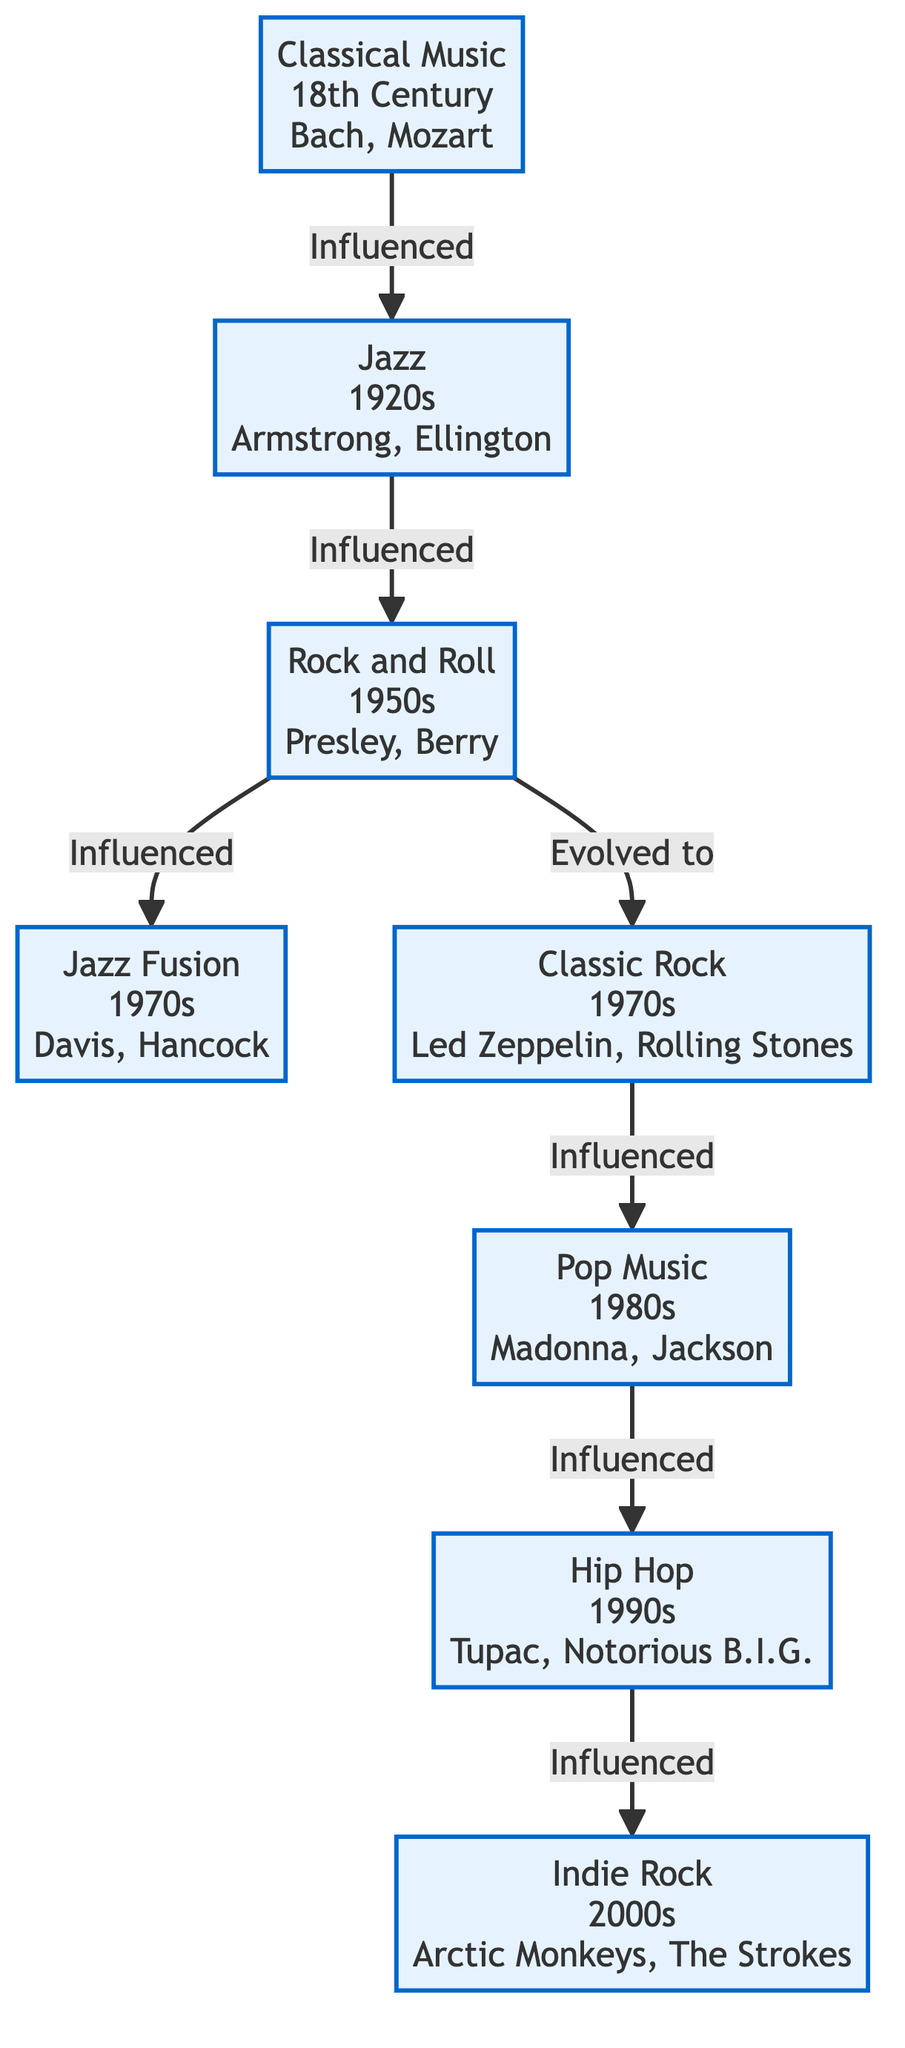What influence does Classical Music have? The diagram indicates that Classical Music directly influences Jazz, as represented by the arrow from Classical Music to Jazz. This shows a directed connection where Classical Music serves as a predecessor to Jazz.
Answer: Jazz Which decade is Pop Music from? By examining the node for Pop Music in the diagram, it is labeled as originating from the 1980s. The information indicates the specific decade associated with this genre.
Answer: 1980s Who are the key artists of Rock and Roll? The diagram provides a description of the Rock and Roll genre, listing its key artists as Elvis Presley and Chuck Berry directly under the node for Rock and Roll. This is straightforward information depicted in the node.
Answer: Elvis Presley, Chuck Berry How many genres are influenced by Rock and Roll? Looking at the Rock and Roll node, there are two directed edges extending from it: one leading to Jazz Fusion and another to Classic Rock. This indicates that Rock and Roll influences two genres.
Answer: 2 What is the relationship between Hip Hop and Indie Rock? The diagram demonstrates that Hip Hop directly influences Indie Rock, as illustrated by the arrow from Hip Hop to Indie Rock. This relationship signifies that Hip Hop contributes to the evolution of Indie Rock.
Answer: Influenced Which music genre serves as a precursor to Jazz Fusion? Analyzing the flow of the diagram, Rock and Roll is shown to directly influence Jazz Fusion with a connecting edge. This indicates that Rock and Roll acts as a predecessor to Jazz Fusion in the timeline of music evolution.
Answer: Rock and Roll Which genre emerged from Classic Rock? The diagram shows an arrow from Classic Rock to Pop, indicating that Pop Music emerged as a result of the influence from Classic Rock. This provides a clear lineage between these two genres.
Answer: Pop How many edges are present in the diagram? By counting the connections (arrows) in the diagram, there are a total of six directed edges that indicate influence or evolution between different music genres. This information gives a sense of the connections illustrated.
Answer: 6 